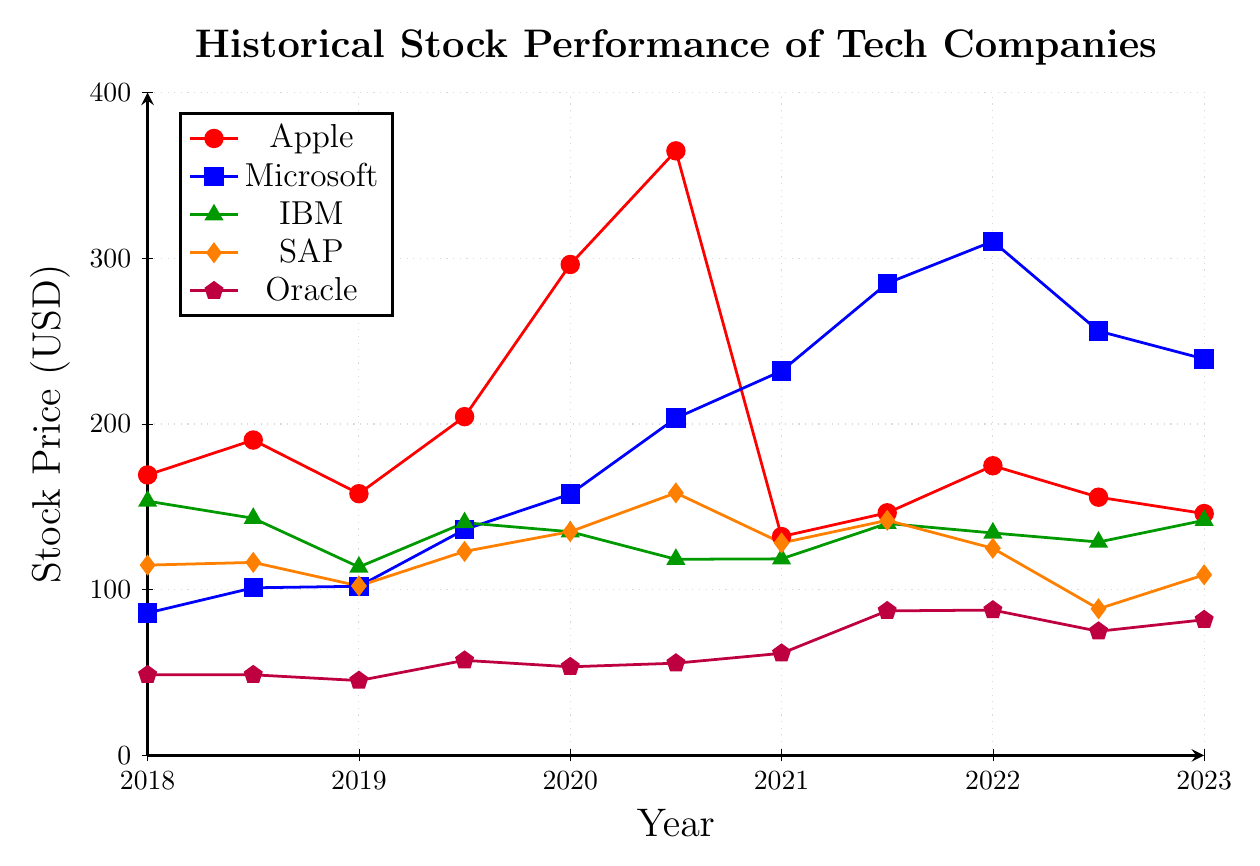What year did Apple reach its peak stock price? Look at the red line representing Apple and identify the highest point on the chart, which occurs at around 2020.5 in July 2020.
Answer: July 2020 How does the stock price of IBM at the beginning of 2019 compare to its price at the end of 2021? Note the green triangles at the start of 2019 and the end of 2021. In January 2019, IBM's price was around 113.67, and in December 2021, it was around 139.97. Thus, the price increased.
Answer: Increased What is the difference between Microsoft's and Oracle's stock prices in July 2021? In July 2021, Microsoft's blue square sits at 284.91, while Oracle's purple pentagon is at 87.21. The difference is 284.91 - 87.21 = 197.70.
Answer: 197.70 Between January 2021 and July 2021, which company showed the greatest absolute change in stock price? Calculate the absolute changes for each company during this period: Apple (132.05 to 146.39, +14.34), Microsoft (231.96 to 284.91, +52.95), IBM (118.61 to 139.97, +21.36), SAP (128.22 to 141.85, +13.63), Oracle (61.60 to 87.21, +25.61). Microsoft shows the greatest change.
Answer: Microsoft Which company had the most volatile stock price trend from 2018 to 2023? Observe fluctuations in the lines. Apple's red line shows significant ups and downs, peaking and then sharply declining, indicating high volatility.
Answer: Apple Did any company have a consistently increasing stock price from 2018 to 2023? Examine the trendlines for consistent upward movement. Microsoft's blue line mostly rises despite a dip in mid-2022, signifying an overall increasing trend.
Answer: Microsoft What was the stock price trend for SAP from January 2022 to January 2023? The orange diamonds show the SAP stock was at 124.97 in January 2022 and fell to 108.95 by January 2023, indicating a downward trend.
Answer: Downward Compare the stock price of Oracle at the start and end of 2020. At the start of 2020, Oracle's price (purple pentagon) was 53.46, and at the end of 2020, it was 55.65. The value increased slightly.
Answer: Increased Which company had the lowest stock price at the end of the plot period in 2023? Check the prices of all companies in 2023. Oracle's purple pentagon is the lowest at 81.86.
Answer: Oracle 